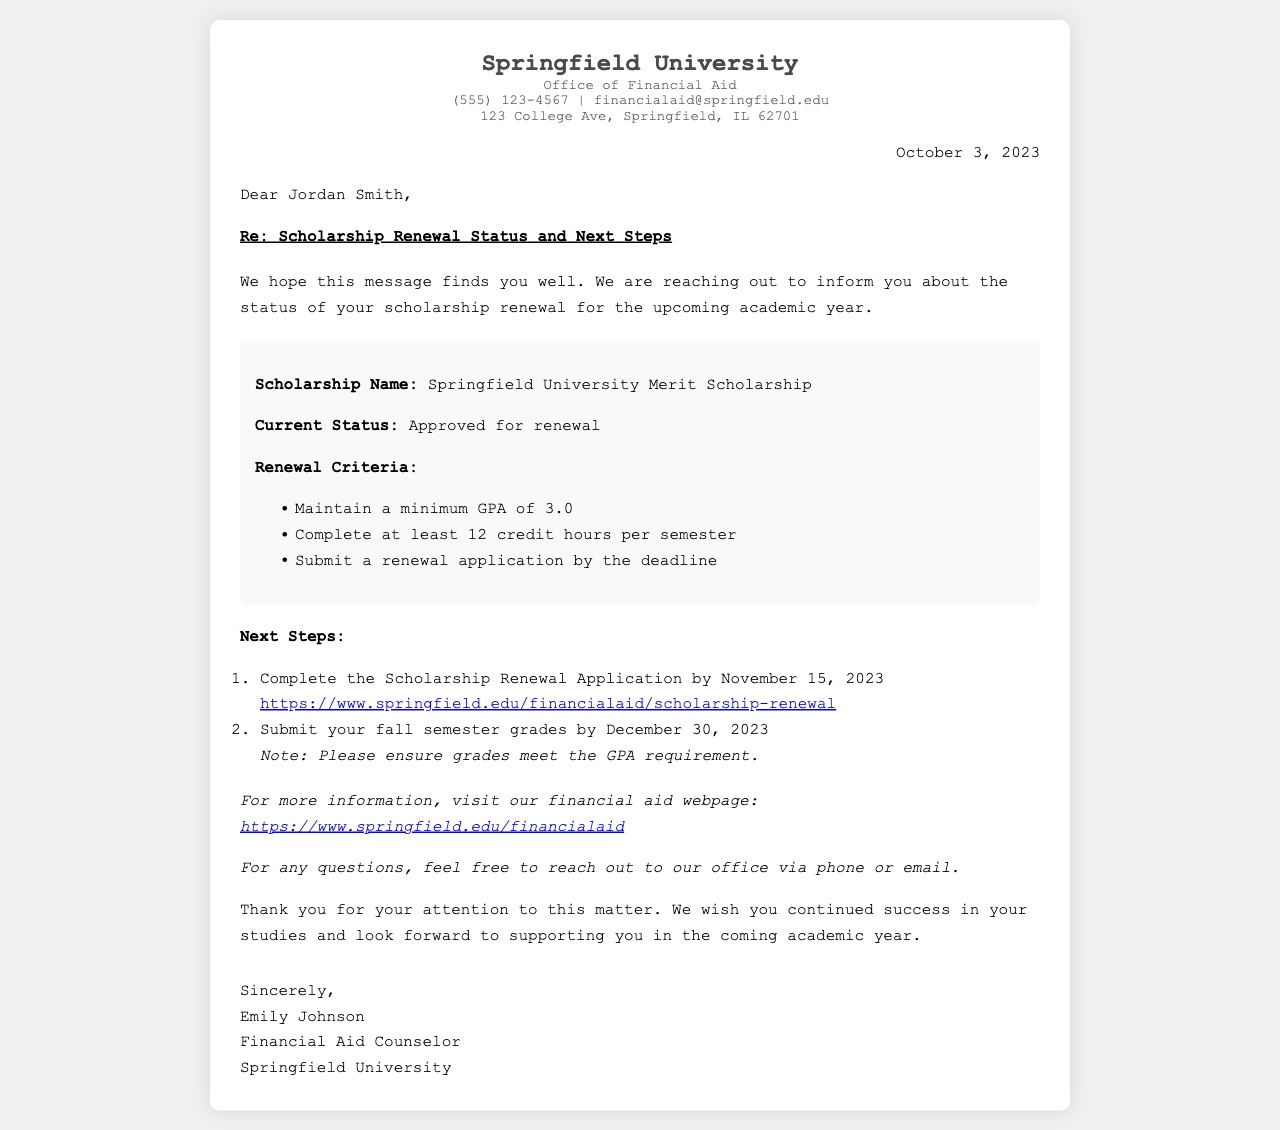What is the scholarship name? The document specifically states the name of the scholarship at the beginning of the scholarship details section.
Answer: Springfield University Merit Scholarship What is the current status of the scholarship? The document clearly outlines the current status of the scholarship under the scholarship details section.
Answer: Approved for renewal What is the minimum GPA required for renewal? The renewal criteria section specifically mentions the GPA requirement for the scholarship.
Answer: 3.0 What is the deadline for submitting the scholarship renewal application? The next steps section indicates the exact date by which the application must be submitted.
Answer: November 15, 2023 By what date must fall semester grades be submitted? The next steps section specifies the deadline for grade submission related to the scholarship renewal.
Answer: December 30, 2023 Who is the Financial Aid Counselor? The document includes the name of the person who signed the letter at the end.
Answer: Emily Johnson What is the contact phone number for the Office of Financial Aid? The letter provides the office's contact information, including their phone number.
Answer: (555) 123-4567 What is the website for more information about financial aid? The resources section mentions the URL for the financial aid webpage.
Answer: https://www.springfield.edu/financialaid What is one of the renewal criteria mentioned? The document outlines several criteria for scholarship renewal in bullet points within the scholarship details.
Answer: Maintain a minimum GPA of 3.0 